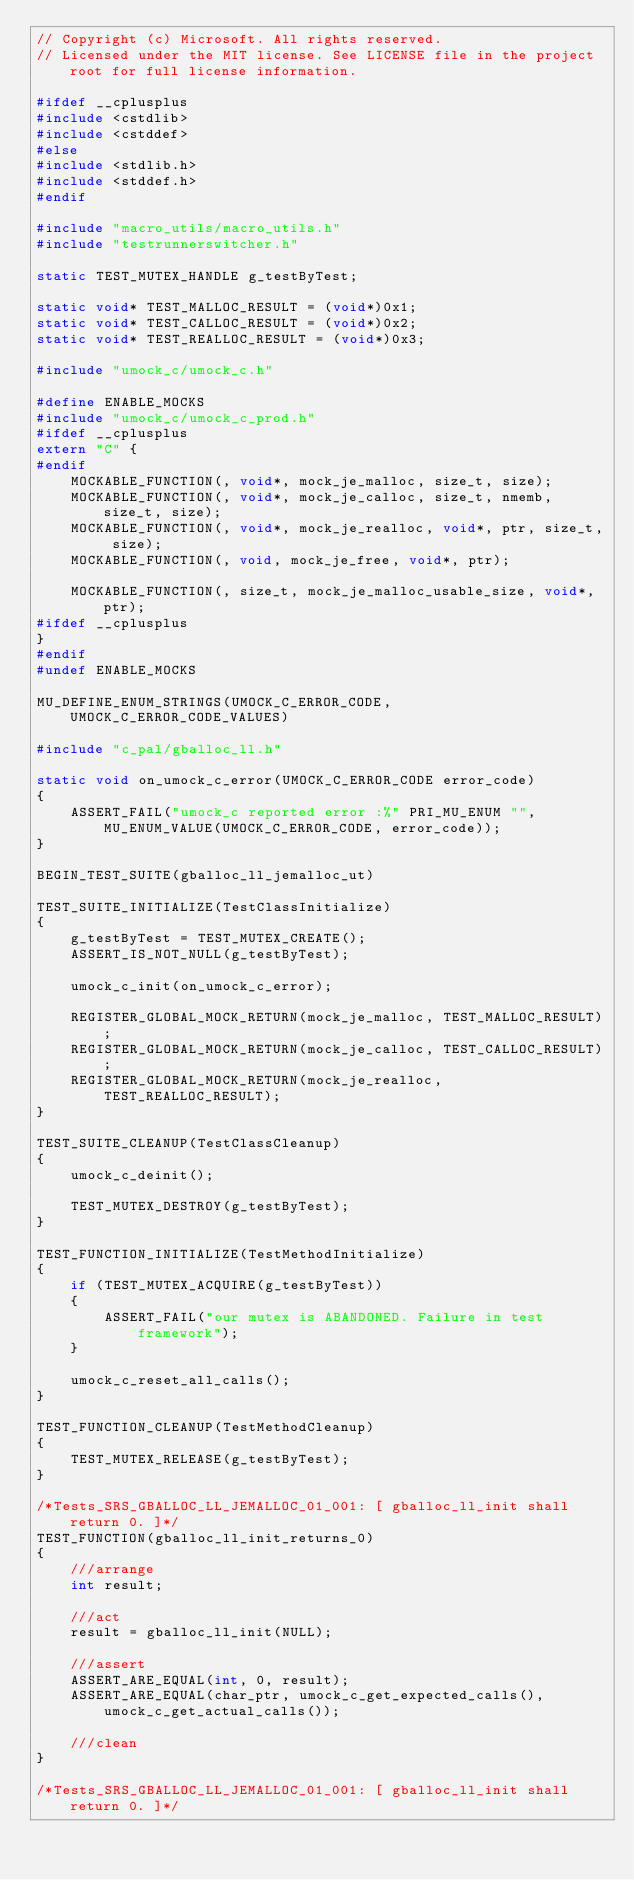<code> <loc_0><loc_0><loc_500><loc_500><_C_>// Copyright (c) Microsoft. All rights reserved.
// Licensed under the MIT license. See LICENSE file in the project root for full license information.

#ifdef __cplusplus
#include <cstdlib>
#include <cstddef>
#else
#include <stdlib.h>
#include <stddef.h>
#endif

#include "macro_utils/macro_utils.h"
#include "testrunnerswitcher.h"

static TEST_MUTEX_HANDLE g_testByTest;

static void* TEST_MALLOC_RESULT = (void*)0x1;
static void* TEST_CALLOC_RESULT = (void*)0x2;
static void* TEST_REALLOC_RESULT = (void*)0x3;

#include "umock_c/umock_c.h"

#define ENABLE_MOCKS
#include "umock_c/umock_c_prod.h"
#ifdef __cplusplus
extern "C" {
#endif
    MOCKABLE_FUNCTION(, void*, mock_je_malloc, size_t, size);
    MOCKABLE_FUNCTION(, void*, mock_je_calloc, size_t, nmemb, size_t, size);
    MOCKABLE_FUNCTION(, void*, mock_je_realloc, void*, ptr, size_t, size);
    MOCKABLE_FUNCTION(, void, mock_je_free, void*, ptr);

    MOCKABLE_FUNCTION(, size_t, mock_je_malloc_usable_size, void*, ptr);
#ifdef __cplusplus
}
#endif
#undef ENABLE_MOCKS

MU_DEFINE_ENUM_STRINGS(UMOCK_C_ERROR_CODE, UMOCK_C_ERROR_CODE_VALUES)

#include "c_pal/gballoc_ll.h"

static void on_umock_c_error(UMOCK_C_ERROR_CODE error_code)
{
    ASSERT_FAIL("umock_c reported error :%" PRI_MU_ENUM "", MU_ENUM_VALUE(UMOCK_C_ERROR_CODE, error_code));
}

BEGIN_TEST_SUITE(gballoc_ll_jemalloc_ut)

TEST_SUITE_INITIALIZE(TestClassInitialize)
{
    g_testByTest = TEST_MUTEX_CREATE();
    ASSERT_IS_NOT_NULL(g_testByTest);

    umock_c_init(on_umock_c_error);

    REGISTER_GLOBAL_MOCK_RETURN(mock_je_malloc, TEST_MALLOC_RESULT);
    REGISTER_GLOBAL_MOCK_RETURN(mock_je_calloc, TEST_CALLOC_RESULT);
    REGISTER_GLOBAL_MOCK_RETURN(mock_je_realloc, TEST_REALLOC_RESULT);
}

TEST_SUITE_CLEANUP(TestClassCleanup)
{
    umock_c_deinit();

    TEST_MUTEX_DESTROY(g_testByTest);
}

TEST_FUNCTION_INITIALIZE(TestMethodInitialize)
{
    if (TEST_MUTEX_ACQUIRE(g_testByTest))
    {
        ASSERT_FAIL("our mutex is ABANDONED. Failure in test framework");
    }

    umock_c_reset_all_calls();
}

TEST_FUNCTION_CLEANUP(TestMethodCleanup)
{
    TEST_MUTEX_RELEASE(g_testByTest);
}

/*Tests_SRS_GBALLOC_LL_JEMALLOC_01_001: [ gballoc_ll_init shall return 0. ]*/
TEST_FUNCTION(gballoc_ll_init_returns_0)
{
    ///arrange
    int result;

    ///act
    result = gballoc_ll_init(NULL);

    ///assert
    ASSERT_ARE_EQUAL(int, 0, result);
    ASSERT_ARE_EQUAL(char_ptr, umock_c_get_expected_calls(), umock_c_get_actual_calls());

    ///clean
}

/*Tests_SRS_GBALLOC_LL_JEMALLOC_01_001: [ gballoc_ll_init shall return 0. ]*/</code> 